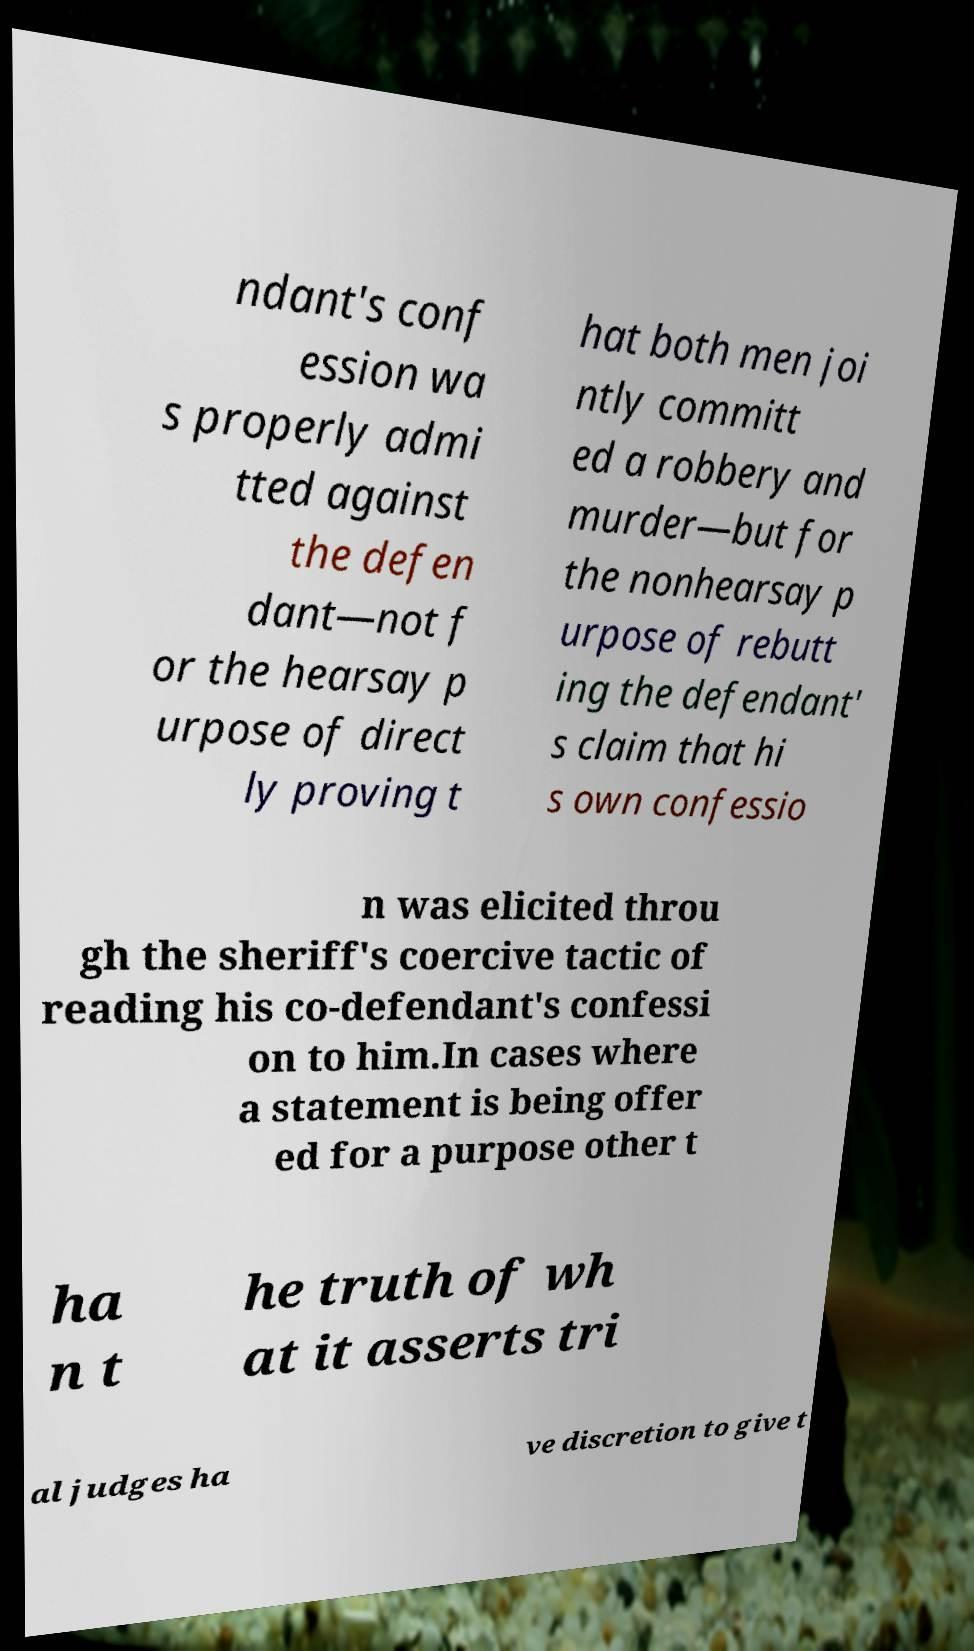Can you read and provide the text displayed in the image?This photo seems to have some interesting text. Can you extract and type it out for me? ndant's conf ession wa s properly admi tted against the defen dant—not f or the hearsay p urpose of direct ly proving t hat both men joi ntly committ ed a robbery and murder—but for the nonhearsay p urpose of rebutt ing the defendant' s claim that hi s own confessio n was elicited throu gh the sheriff's coercive tactic of reading his co-defendant's confessi on to him.In cases where a statement is being offer ed for a purpose other t ha n t he truth of wh at it asserts tri al judges ha ve discretion to give t 